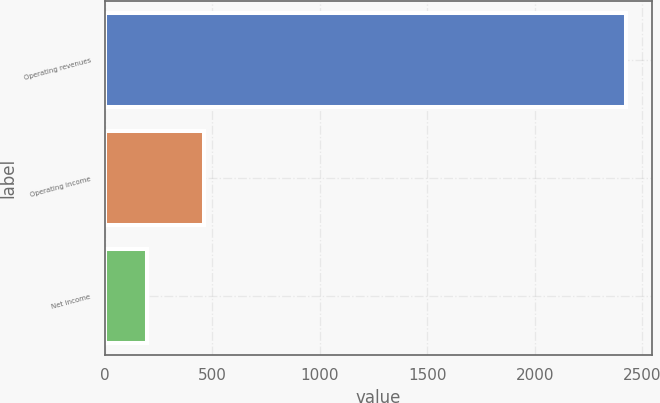<chart> <loc_0><loc_0><loc_500><loc_500><bar_chart><fcel>Operating revenues<fcel>Operating income<fcel>Net income<nl><fcel>2424<fcel>463<fcel>197<nl></chart> 